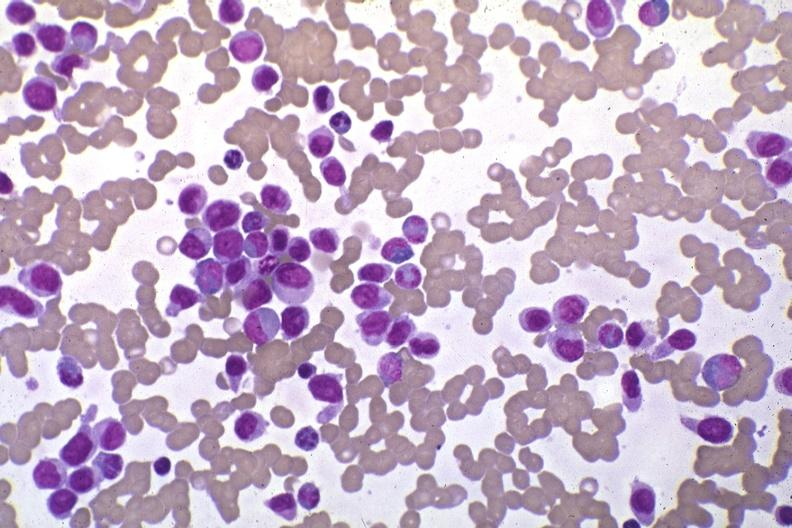s antitrypsin present?
Answer the question using a single word or phrase. No 